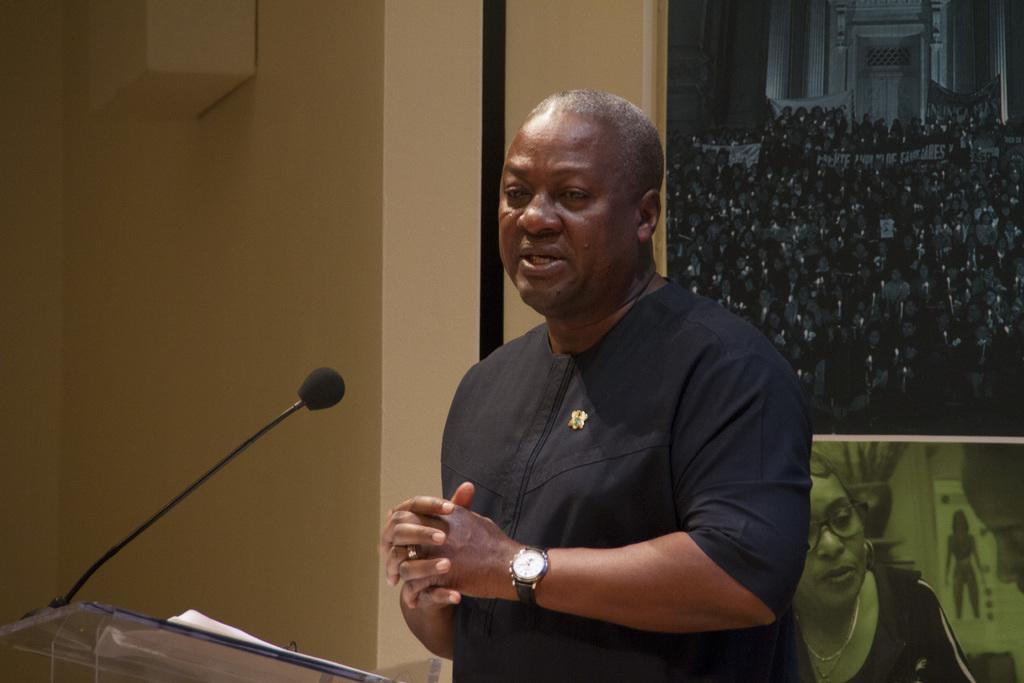Describe this image in one or two sentences. In the image we can see a man standing, wearing clothes, wrist watch, finger ring and the man is talking. Here we can see the microphone, behind him there is the poster, in the poster we can see there are many people and a building. Here we can see the wall and the papers. 